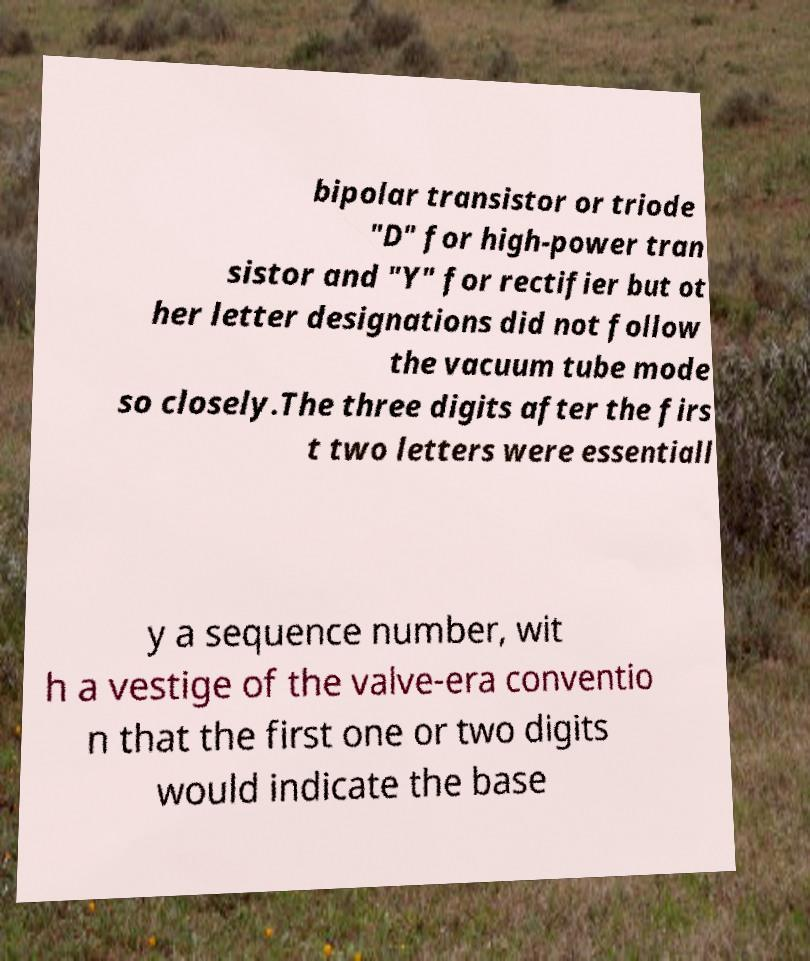Please read and relay the text visible in this image. What does it say? bipolar transistor or triode "D" for high-power tran sistor and "Y" for rectifier but ot her letter designations did not follow the vacuum tube mode so closely.The three digits after the firs t two letters were essentiall y a sequence number, wit h a vestige of the valve-era conventio n that the first one or two digits would indicate the base 